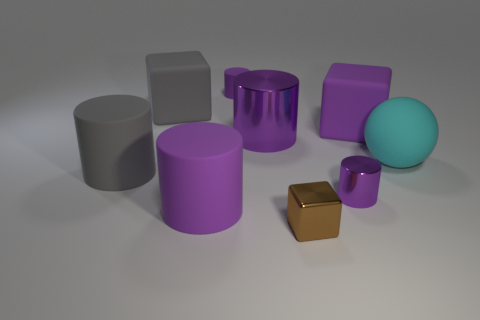Is the number of matte blocks right of the small brown block the same as the number of small blue shiny spheres?
Offer a very short reply. No. Is the cyan matte object the same size as the gray cylinder?
Ensure brevity in your answer.  Yes. The cube that is both to the right of the big gray matte cube and left of the small purple metal cylinder is made of what material?
Keep it short and to the point. Metal. What number of large purple rubber objects have the same shape as the large cyan rubber object?
Offer a very short reply. 0. What material is the large gray object behind the sphere?
Ensure brevity in your answer.  Rubber. Is the number of tiny purple metallic cylinders right of the cyan rubber sphere less than the number of spheres?
Your answer should be compact. Yes. Is the big cyan matte object the same shape as the tiny brown object?
Your answer should be very brief. No. Are there any other things that are the same shape as the cyan thing?
Your response must be concise. No. Are there any small yellow cubes?
Your answer should be very brief. No. Is the shape of the tiny rubber thing the same as the large gray matte thing in front of the cyan thing?
Your answer should be very brief. Yes. 